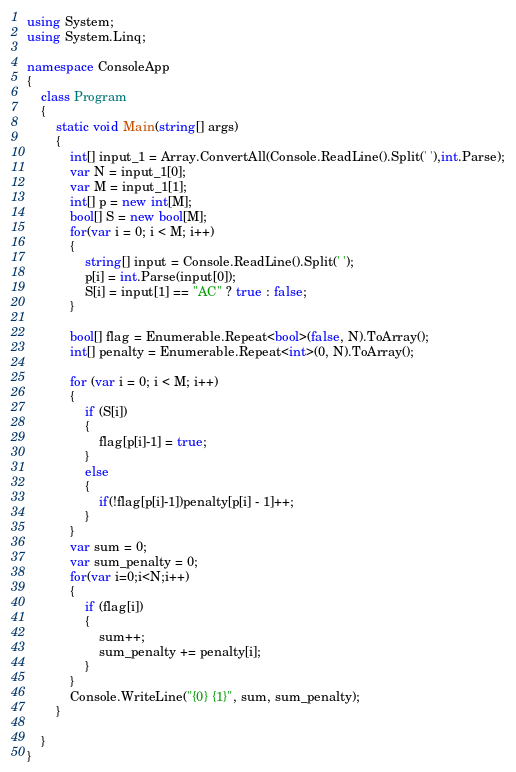<code> <loc_0><loc_0><loc_500><loc_500><_C#_>using System;
using System.Linq;

namespace ConsoleApp
{
    class Program
    {
        static void Main(string[] args)
        {
            int[] input_1 = Array.ConvertAll(Console.ReadLine().Split(' '),int.Parse);
            var N = input_1[0];
            var M = input_1[1];
            int[] p = new int[M];
            bool[] S = new bool[M];
            for(var i = 0; i < M; i++)
            {
                string[] input = Console.ReadLine().Split(' ');
                p[i] = int.Parse(input[0]);
                S[i] = input[1] == "AC" ? true : false;
            }

            bool[] flag = Enumerable.Repeat<bool>(false, N).ToArray();
            int[] penalty = Enumerable.Repeat<int>(0, N).ToArray();

            for (var i = 0; i < M; i++)
            {
                if (S[i])
                {
                    flag[p[i]-1] = true;
                }
                else
                {
                    if(!flag[p[i]-1])penalty[p[i] - 1]++;
                }
            }
            var sum = 0;
            var sum_penalty = 0;
            for(var i=0;i<N;i++)
            {
                if (flag[i])
                {
                    sum++;
                    sum_penalty += penalty[i];
                }
            }
            Console.WriteLine("{0} {1}", sum, sum_penalty);
        }

    }
}
</code> 